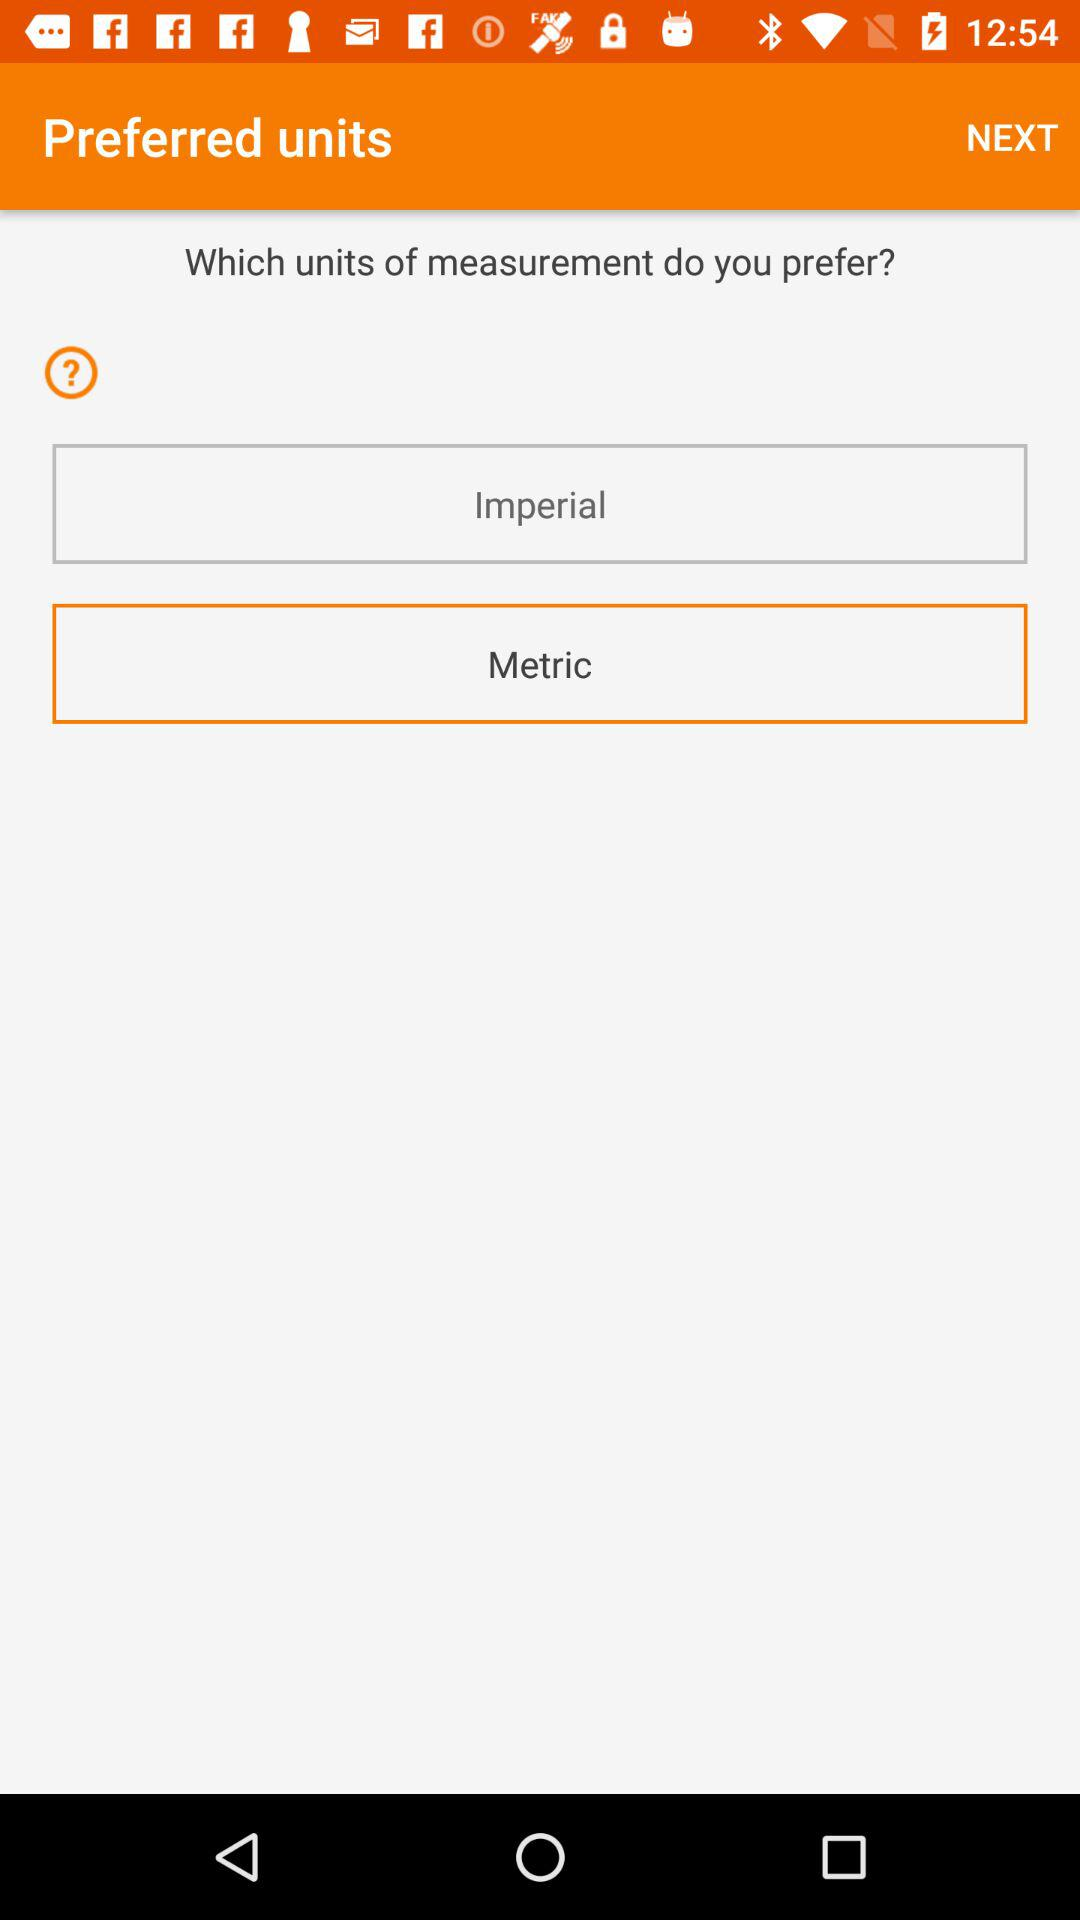How many units of measurement are available?
Answer the question using a single word or phrase. 2 